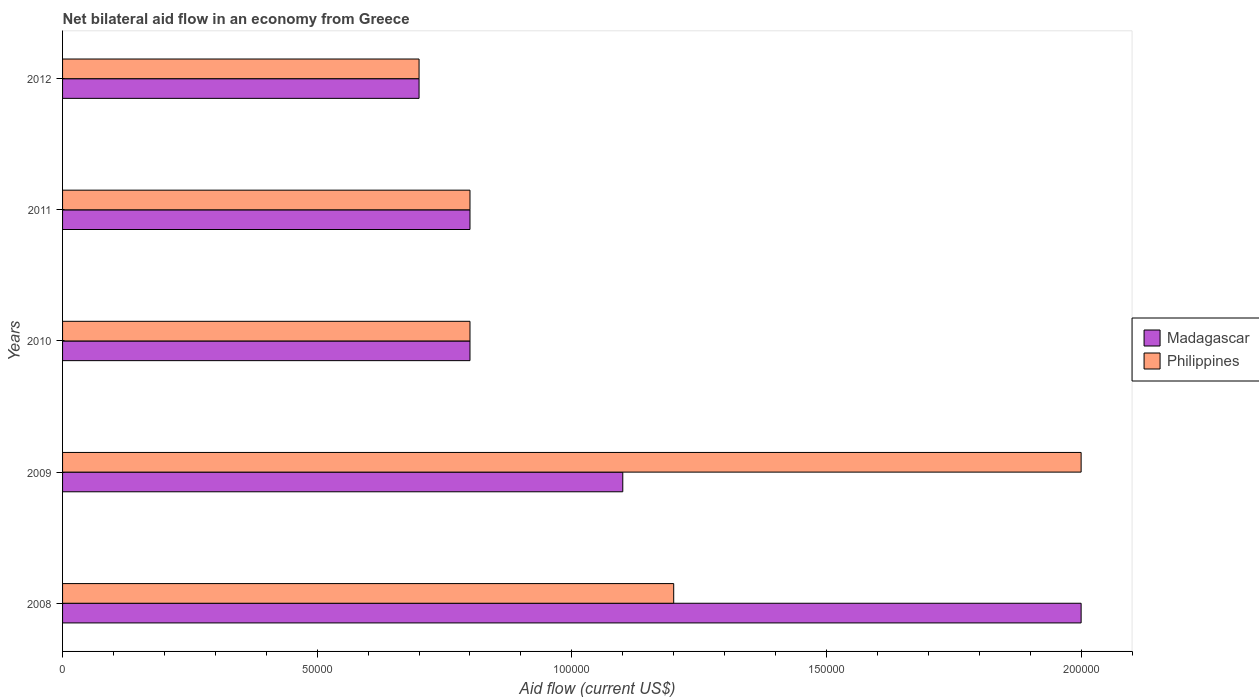How many groups of bars are there?
Offer a very short reply. 5. How many bars are there on the 3rd tick from the top?
Offer a terse response. 2. How many bars are there on the 5th tick from the bottom?
Your answer should be very brief. 2. What is the label of the 1st group of bars from the top?
Give a very brief answer. 2012. In how many cases, is the number of bars for a given year not equal to the number of legend labels?
Provide a short and direct response. 0. What is the net bilateral aid flow in Philippines in 2011?
Offer a very short reply. 8.00e+04. Across all years, what is the maximum net bilateral aid flow in Philippines?
Make the answer very short. 2.00e+05. In which year was the net bilateral aid flow in Philippines minimum?
Ensure brevity in your answer.  2012. What is the total net bilateral aid flow in Madagascar in the graph?
Keep it short and to the point. 5.40e+05. What is the difference between the net bilateral aid flow in Madagascar in 2010 and the net bilateral aid flow in Philippines in 2009?
Offer a terse response. -1.20e+05. What is the average net bilateral aid flow in Philippines per year?
Give a very brief answer. 1.10e+05. In the year 2008, what is the difference between the net bilateral aid flow in Philippines and net bilateral aid flow in Madagascar?
Provide a short and direct response. -8.00e+04. What is the ratio of the net bilateral aid flow in Madagascar in 2009 to that in 2010?
Ensure brevity in your answer.  1.38. Is the net bilateral aid flow in Madagascar in 2011 less than that in 2012?
Provide a short and direct response. No. What is the difference between the highest and the lowest net bilateral aid flow in Madagascar?
Keep it short and to the point. 1.30e+05. Is the sum of the net bilateral aid flow in Madagascar in 2009 and 2012 greater than the maximum net bilateral aid flow in Philippines across all years?
Make the answer very short. No. What does the 2nd bar from the top in 2009 represents?
Ensure brevity in your answer.  Madagascar. How many bars are there?
Your answer should be compact. 10. Are all the bars in the graph horizontal?
Offer a very short reply. Yes. Are the values on the major ticks of X-axis written in scientific E-notation?
Make the answer very short. No. Does the graph contain any zero values?
Your response must be concise. No. Does the graph contain grids?
Give a very brief answer. No. How many legend labels are there?
Keep it short and to the point. 2. How are the legend labels stacked?
Keep it short and to the point. Vertical. What is the title of the graph?
Keep it short and to the point. Net bilateral aid flow in an economy from Greece. Does "Ethiopia" appear as one of the legend labels in the graph?
Give a very brief answer. No. What is the Aid flow (current US$) of Madagascar in 2008?
Offer a very short reply. 2.00e+05. What is the Aid flow (current US$) in Philippines in 2008?
Provide a succinct answer. 1.20e+05. What is the Aid flow (current US$) of Madagascar in 2009?
Offer a very short reply. 1.10e+05. What is the Aid flow (current US$) of Philippines in 2009?
Provide a succinct answer. 2.00e+05. What is the Aid flow (current US$) in Madagascar in 2010?
Make the answer very short. 8.00e+04. What is the Aid flow (current US$) of Philippines in 2010?
Your answer should be compact. 8.00e+04. What is the Aid flow (current US$) in Philippines in 2011?
Offer a very short reply. 8.00e+04. What is the Aid flow (current US$) in Philippines in 2012?
Provide a succinct answer. 7.00e+04. Across all years, what is the maximum Aid flow (current US$) in Madagascar?
Your answer should be very brief. 2.00e+05. Across all years, what is the maximum Aid flow (current US$) in Philippines?
Your answer should be compact. 2.00e+05. Across all years, what is the minimum Aid flow (current US$) in Philippines?
Give a very brief answer. 7.00e+04. What is the total Aid flow (current US$) in Madagascar in the graph?
Provide a succinct answer. 5.40e+05. What is the total Aid flow (current US$) in Philippines in the graph?
Make the answer very short. 5.50e+05. What is the difference between the Aid flow (current US$) of Madagascar in 2008 and that in 2009?
Provide a succinct answer. 9.00e+04. What is the difference between the Aid flow (current US$) of Madagascar in 2008 and that in 2010?
Offer a very short reply. 1.20e+05. What is the difference between the Aid flow (current US$) in Madagascar in 2008 and that in 2011?
Keep it short and to the point. 1.20e+05. What is the difference between the Aid flow (current US$) of Madagascar in 2008 and that in 2012?
Offer a terse response. 1.30e+05. What is the difference between the Aid flow (current US$) in Philippines in 2008 and that in 2012?
Your answer should be compact. 5.00e+04. What is the difference between the Aid flow (current US$) in Philippines in 2009 and that in 2010?
Give a very brief answer. 1.20e+05. What is the difference between the Aid flow (current US$) of Philippines in 2009 and that in 2011?
Give a very brief answer. 1.20e+05. What is the difference between the Aid flow (current US$) of Philippines in 2010 and that in 2012?
Keep it short and to the point. 10000. What is the difference between the Aid flow (current US$) of Madagascar in 2011 and that in 2012?
Offer a terse response. 10000. What is the difference between the Aid flow (current US$) in Philippines in 2011 and that in 2012?
Your answer should be very brief. 10000. What is the difference between the Aid flow (current US$) of Madagascar in 2008 and the Aid flow (current US$) of Philippines in 2009?
Offer a terse response. 0. What is the difference between the Aid flow (current US$) of Madagascar in 2008 and the Aid flow (current US$) of Philippines in 2011?
Provide a short and direct response. 1.20e+05. What is the difference between the Aid flow (current US$) of Madagascar in 2009 and the Aid flow (current US$) of Philippines in 2010?
Your answer should be very brief. 3.00e+04. What is the difference between the Aid flow (current US$) of Madagascar in 2009 and the Aid flow (current US$) of Philippines in 2011?
Offer a very short reply. 3.00e+04. What is the difference between the Aid flow (current US$) in Madagascar in 2010 and the Aid flow (current US$) in Philippines in 2011?
Provide a short and direct response. 0. What is the difference between the Aid flow (current US$) of Madagascar in 2010 and the Aid flow (current US$) of Philippines in 2012?
Offer a terse response. 10000. What is the difference between the Aid flow (current US$) in Madagascar in 2011 and the Aid flow (current US$) in Philippines in 2012?
Offer a very short reply. 10000. What is the average Aid flow (current US$) in Madagascar per year?
Provide a short and direct response. 1.08e+05. In the year 2008, what is the difference between the Aid flow (current US$) of Madagascar and Aid flow (current US$) of Philippines?
Provide a short and direct response. 8.00e+04. In the year 2009, what is the difference between the Aid flow (current US$) in Madagascar and Aid flow (current US$) in Philippines?
Make the answer very short. -9.00e+04. What is the ratio of the Aid flow (current US$) of Madagascar in 2008 to that in 2009?
Provide a succinct answer. 1.82. What is the ratio of the Aid flow (current US$) of Philippines in 2008 to that in 2009?
Ensure brevity in your answer.  0.6. What is the ratio of the Aid flow (current US$) in Madagascar in 2008 to that in 2010?
Your answer should be compact. 2.5. What is the ratio of the Aid flow (current US$) in Philippines in 2008 to that in 2010?
Offer a terse response. 1.5. What is the ratio of the Aid flow (current US$) in Madagascar in 2008 to that in 2011?
Give a very brief answer. 2.5. What is the ratio of the Aid flow (current US$) in Madagascar in 2008 to that in 2012?
Your response must be concise. 2.86. What is the ratio of the Aid flow (current US$) in Philippines in 2008 to that in 2012?
Offer a very short reply. 1.71. What is the ratio of the Aid flow (current US$) in Madagascar in 2009 to that in 2010?
Make the answer very short. 1.38. What is the ratio of the Aid flow (current US$) in Madagascar in 2009 to that in 2011?
Your answer should be compact. 1.38. What is the ratio of the Aid flow (current US$) in Madagascar in 2009 to that in 2012?
Provide a succinct answer. 1.57. What is the ratio of the Aid flow (current US$) of Philippines in 2009 to that in 2012?
Offer a very short reply. 2.86. What is the ratio of the Aid flow (current US$) of Madagascar in 2010 to that in 2011?
Ensure brevity in your answer.  1. What is the ratio of the Aid flow (current US$) of Madagascar in 2011 to that in 2012?
Make the answer very short. 1.14. What is the ratio of the Aid flow (current US$) of Philippines in 2011 to that in 2012?
Ensure brevity in your answer.  1.14. What is the difference between the highest and the second highest Aid flow (current US$) in Philippines?
Your answer should be compact. 8.00e+04. What is the difference between the highest and the lowest Aid flow (current US$) of Madagascar?
Make the answer very short. 1.30e+05. 